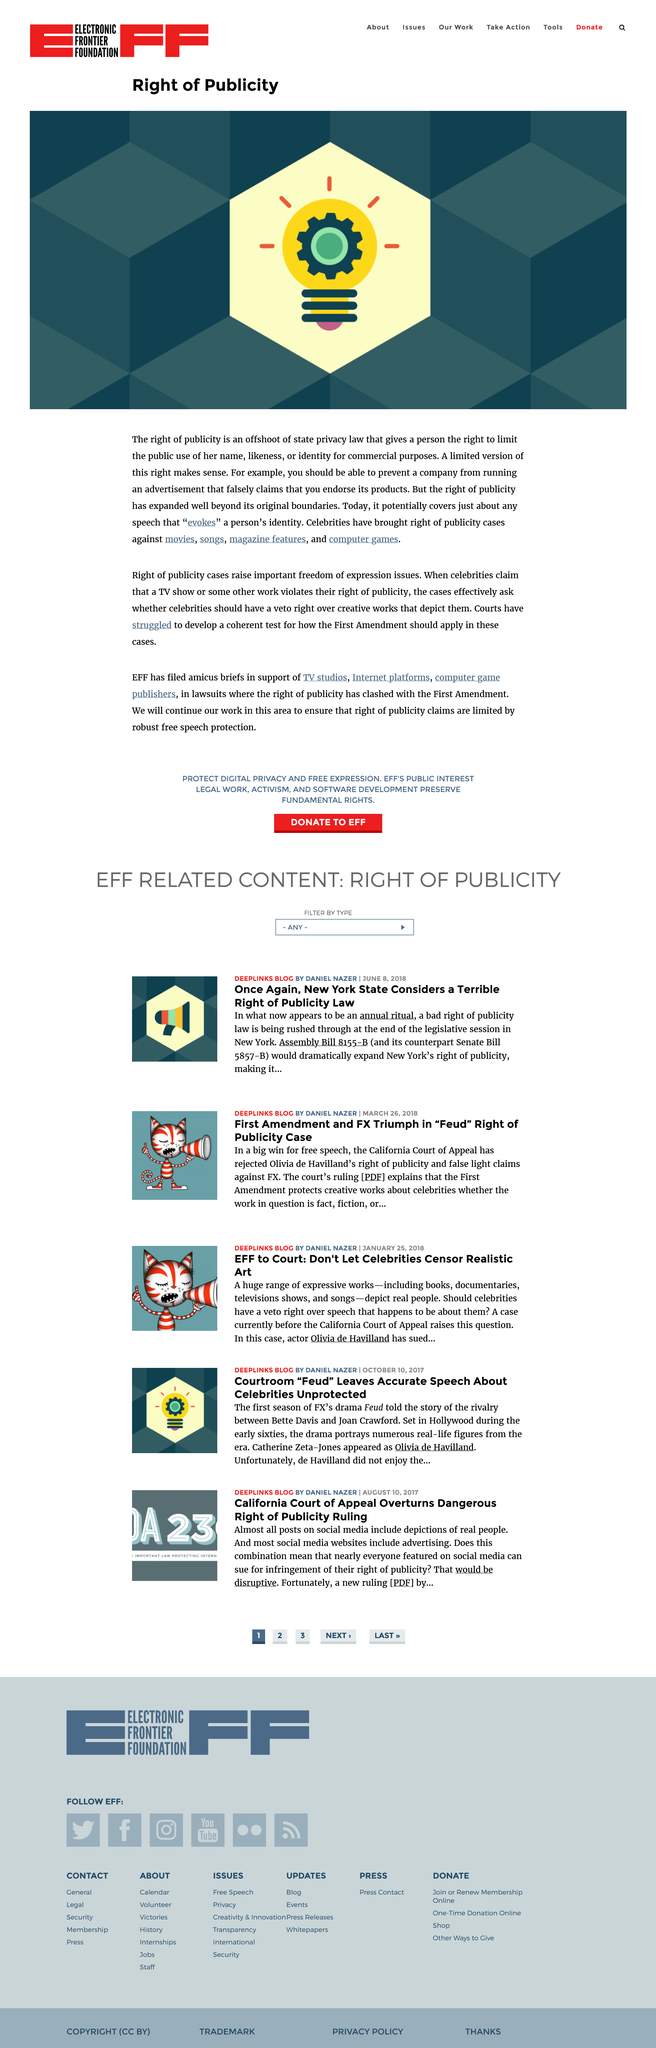Draw attention to some important aspects in this diagram. Celebrities have brought numerous right of publicity cases against movies. Yes, it is an offshoot of state privacy laws. It is a fact that celebrity individuals have brought legal cases against songs that infringe upon their right of publicity, as these cases have been widely reported and documented. 